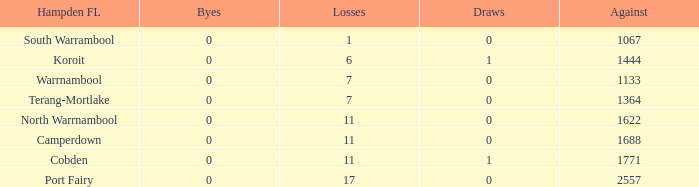What were the losses when the byes were less than 0? None. 